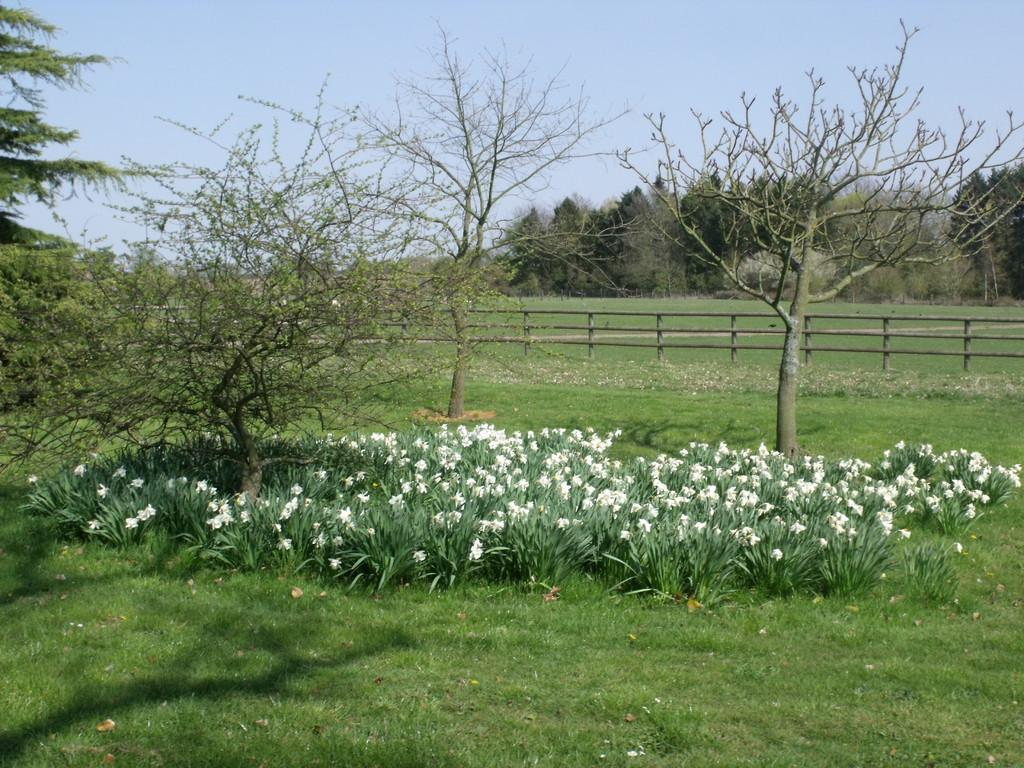What is located in the center of the image? In the center of the image, there are plants, grass, flowers, trees, and a fence. Can you describe the vegetation in the center of the image? The vegetation in the center of the image includes plants, grass, flowers, and trees. What is visible in the background of the image? In the background of the image, the sky, clouds, and trees can be seen. Can you tell me where the fireman is standing in the image? There is no fireman present in the image. How many brothers are visible in the image? There are no brothers present in the image. 